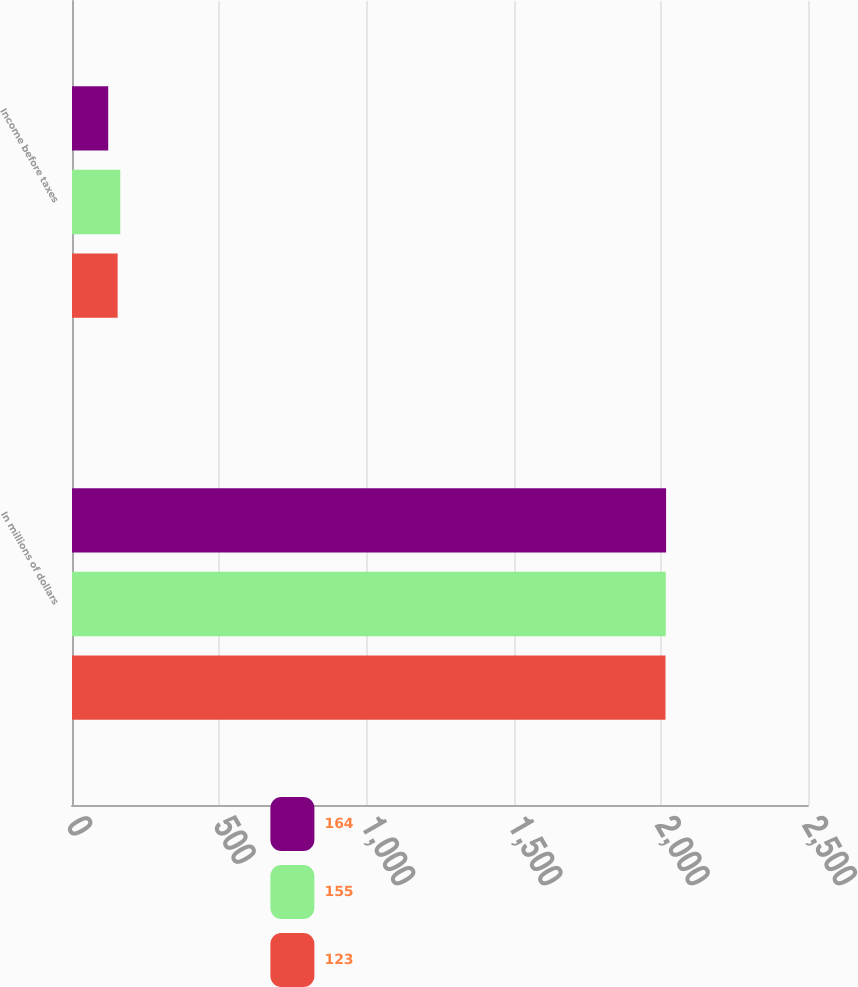<chart> <loc_0><loc_0><loc_500><loc_500><stacked_bar_chart><ecel><fcel>In millions of dollars<fcel>Income before taxes<nl><fcel>164<fcel>2018<fcel>123<nl><fcel>155<fcel>2017<fcel>164<nl><fcel>123<fcel>2016<fcel>155<nl></chart> 